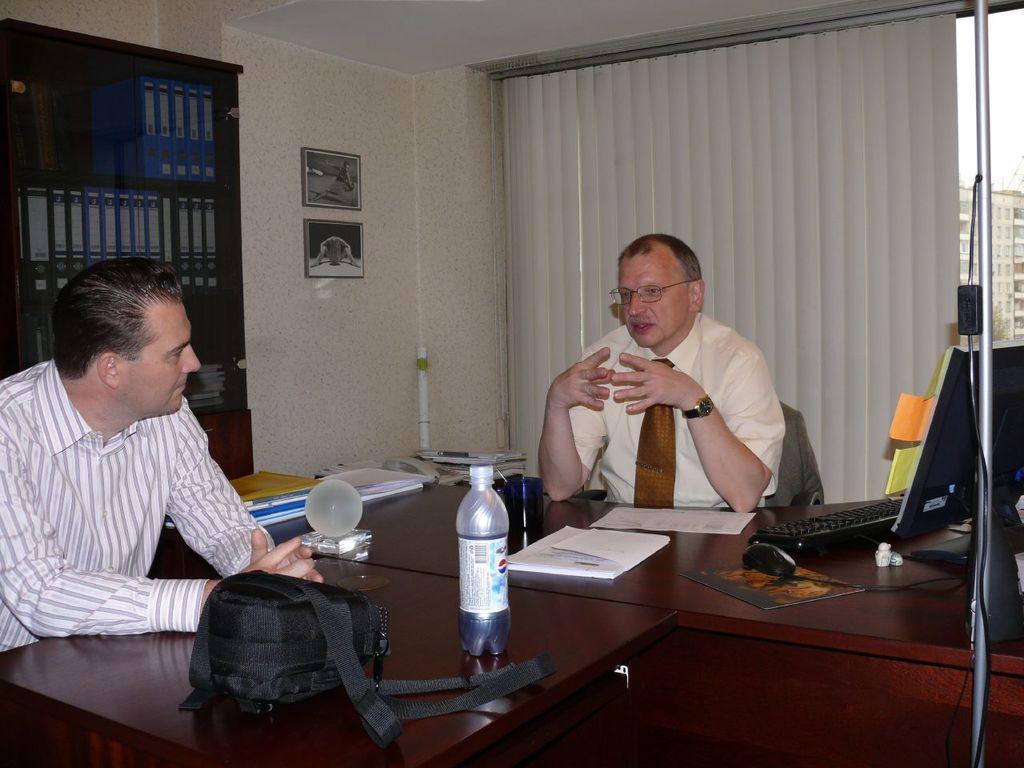Please provide a concise description of this image. Man in the middle of the picture wearing cream shirt and brown tie is sitting on the chair and he is talking to the man on the opposite side who is wearing white checks shirt. In front of them, we see a table on which monitor, keyboard, mouse, papers, water bottle, books, files and black bag are placed. Behind them, we see a rack in which many books are placed. Beside that, we see a white wall on which photo frames are placed. Beside that, we see a window blind from which we see many buildings and this picture is clicked inside the room. 